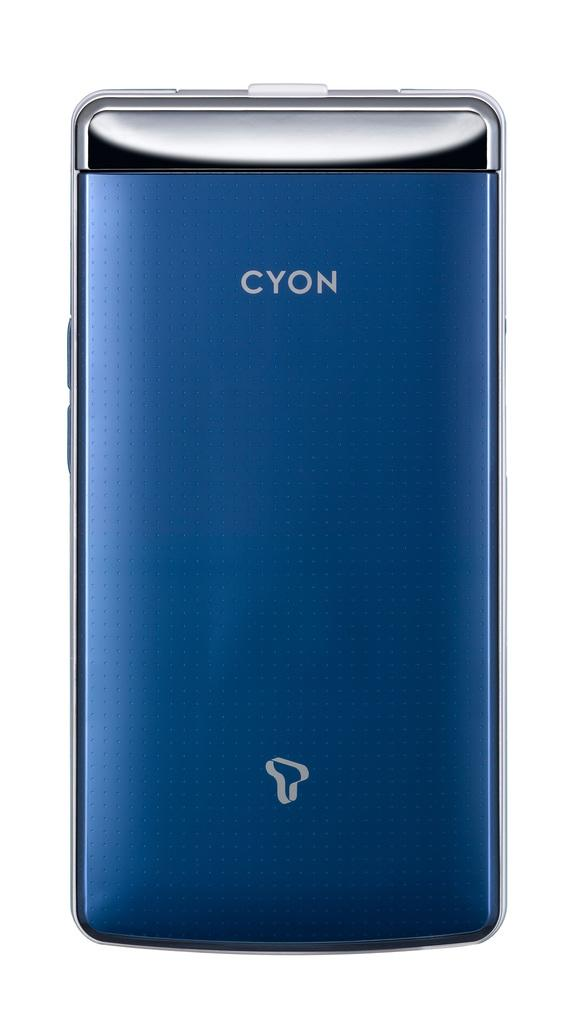What is the main subject of the picture? There is an object in the picture. Can you describe the color of the object? The object is blue in color. What is placed on the object? There is a log on the object. What is written on the log? Something is written on the log. What color is the background of the image? The background of the image is white. How many sisters are holding gloves in the image? There are no sisters or gloves present in the image. 